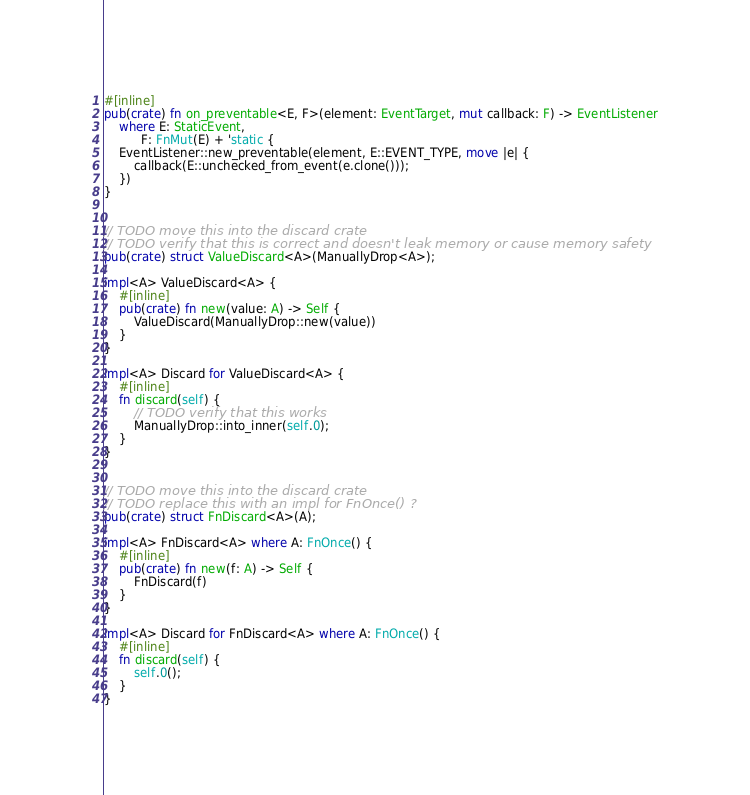Convert code to text. <code><loc_0><loc_0><loc_500><loc_500><_Rust_>
#[inline]
pub(crate) fn on_preventable<E, F>(element: EventTarget, mut callback: F) -> EventListener
    where E: StaticEvent,
          F: FnMut(E) + 'static {
    EventListener::new_preventable(element, E::EVENT_TYPE, move |e| {
        callback(E::unchecked_from_event(e.clone()));
    })
}


// TODO move this into the discard crate
// TODO verify that this is correct and doesn't leak memory or cause memory safety
pub(crate) struct ValueDiscard<A>(ManuallyDrop<A>);

impl<A> ValueDiscard<A> {
    #[inline]
    pub(crate) fn new(value: A) -> Self {
        ValueDiscard(ManuallyDrop::new(value))
    }
}

impl<A> Discard for ValueDiscard<A> {
    #[inline]
    fn discard(self) {
        // TODO verify that this works
        ManuallyDrop::into_inner(self.0);
    }
}


// TODO move this into the discard crate
// TODO replace this with an impl for FnOnce() ?
pub(crate) struct FnDiscard<A>(A);

impl<A> FnDiscard<A> where A: FnOnce() {
    #[inline]
    pub(crate) fn new(f: A) -> Self {
        FnDiscard(f)
    }
}

impl<A> Discard for FnDiscard<A> where A: FnOnce() {
    #[inline]
    fn discard(self) {
        self.0();
    }
}
</code> 